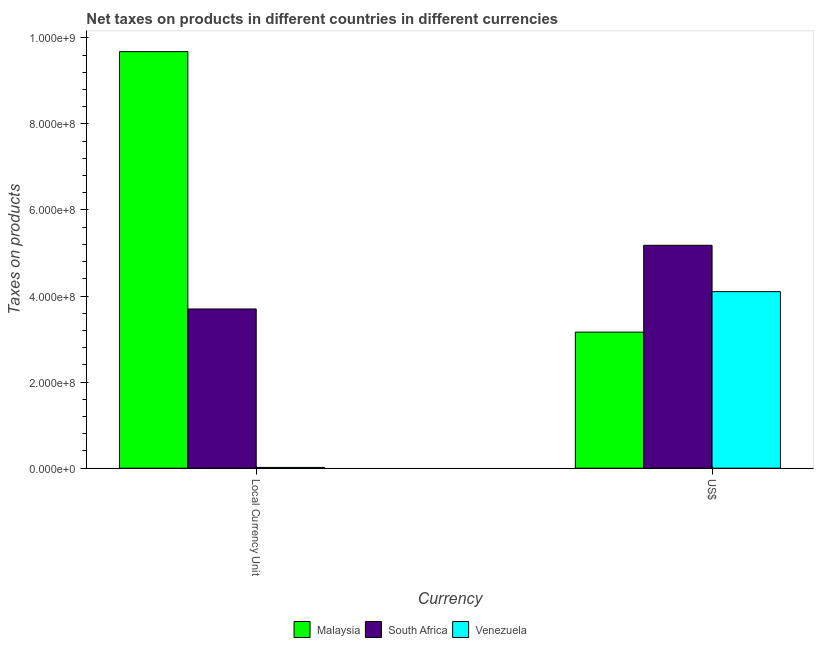How many different coloured bars are there?
Provide a succinct answer. 3. How many groups of bars are there?
Ensure brevity in your answer.  2. Are the number of bars per tick equal to the number of legend labels?
Your answer should be compact. Yes. What is the label of the 2nd group of bars from the left?
Provide a short and direct response. US$. What is the net taxes in constant 2005 us$ in Venezuela?
Ensure brevity in your answer.  1.80e+06. Across all countries, what is the maximum net taxes in us$?
Ensure brevity in your answer.  5.18e+08. Across all countries, what is the minimum net taxes in us$?
Provide a succinct answer. 3.16e+08. In which country was the net taxes in constant 2005 us$ maximum?
Your answer should be very brief. Malaysia. In which country was the net taxes in us$ minimum?
Your answer should be compact. Malaysia. What is the total net taxes in constant 2005 us$ in the graph?
Make the answer very short. 1.34e+09. What is the difference between the net taxes in us$ in Venezuela and that in Malaysia?
Make the answer very short. 9.41e+07. What is the difference between the net taxes in us$ in Venezuela and the net taxes in constant 2005 us$ in South Africa?
Provide a succinct answer. 4.03e+07. What is the average net taxes in constant 2005 us$ per country?
Your answer should be very brief. 4.47e+08. What is the difference between the net taxes in constant 2005 us$ and net taxes in us$ in Venezuela?
Give a very brief answer. -4.09e+08. What is the ratio of the net taxes in constant 2005 us$ in South Africa to that in Malaysia?
Give a very brief answer. 0.38. Is the net taxes in us$ in Venezuela less than that in Malaysia?
Make the answer very short. No. In how many countries, is the net taxes in us$ greater than the average net taxes in us$ taken over all countries?
Your response must be concise. 1. What does the 1st bar from the left in US$ represents?
Your answer should be compact. Malaysia. What does the 1st bar from the right in Local Currency Unit represents?
Provide a succinct answer. Venezuela. How many bars are there?
Your response must be concise. 6. Are all the bars in the graph horizontal?
Your response must be concise. No. How many countries are there in the graph?
Make the answer very short. 3. What is the difference between two consecutive major ticks on the Y-axis?
Offer a very short reply. 2.00e+08. Does the graph contain grids?
Offer a terse response. No. How many legend labels are there?
Give a very brief answer. 3. How are the legend labels stacked?
Keep it short and to the point. Horizontal. What is the title of the graph?
Give a very brief answer. Net taxes on products in different countries in different currencies. Does "Cambodia" appear as one of the legend labels in the graph?
Provide a succinct answer. No. What is the label or title of the X-axis?
Provide a succinct answer. Currency. What is the label or title of the Y-axis?
Provide a succinct answer. Taxes on products. What is the Taxes on products in Malaysia in Local Currency Unit?
Make the answer very short. 9.68e+08. What is the Taxes on products in South Africa in Local Currency Unit?
Your answer should be compact. 3.70e+08. What is the Taxes on products of Venezuela in Local Currency Unit?
Provide a short and direct response. 1.80e+06. What is the Taxes on products in Malaysia in US$?
Your answer should be very brief. 3.16e+08. What is the Taxes on products of South Africa in US$?
Offer a terse response. 5.18e+08. What is the Taxes on products in Venezuela in US$?
Your answer should be very brief. 4.10e+08. Across all Currency, what is the maximum Taxes on products in Malaysia?
Your response must be concise. 9.68e+08. Across all Currency, what is the maximum Taxes on products of South Africa?
Ensure brevity in your answer.  5.18e+08. Across all Currency, what is the maximum Taxes on products of Venezuela?
Your answer should be very brief. 4.10e+08. Across all Currency, what is the minimum Taxes on products of Malaysia?
Provide a succinct answer. 3.16e+08. Across all Currency, what is the minimum Taxes on products in South Africa?
Your answer should be compact. 3.70e+08. Across all Currency, what is the minimum Taxes on products in Venezuela?
Give a very brief answer. 1.80e+06. What is the total Taxes on products in Malaysia in the graph?
Your answer should be compact. 1.28e+09. What is the total Taxes on products in South Africa in the graph?
Your response must be concise. 8.88e+08. What is the total Taxes on products of Venezuela in the graph?
Your answer should be very brief. 4.12e+08. What is the difference between the Taxes on products of Malaysia in Local Currency Unit and that in US$?
Make the answer very short. 6.52e+08. What is the difference between the Taxes on products in South Africa in Local Currency Unit and that in US$?
Provide a short and direct response. -1.48e+08. What is the difference between the Taxes on products in Venezuela in Local Currency Unit and that in US$?
Offer a terse response. -4.09e+08. What is the difference between the Taxes on products of Malaysia in Local Currency Unit and the Taxes on products of South Africa in US$?
Make the answer very short. 4.50e+08. What is the difference between the Taxes on products in Malaysia in Local Currency Unit and the Taxes on products in Venezuela in US$?
Offer a terse response. 5.58e+08. What is the difference between the Taxes on products of South Africa in Local Currency Unit and the Taxes on products of Venezuela in US$?
Provide a short and direct response. -4.03e+07. What is the average Taxes on products of Malaysia per Currency?
Offer a terse response. 6.42e+08. What is the average Taxes on products of South Africa per Currency?
Provide a short and direct response. 4.44e+08. What is the average Taxes on products in Venezuela per Currency?
Make the answer very short. 2.06e+08. What is the difference between the Taxes on products of Malaysia and Taxes on products of South Africa in Local Currency Unit?
Provide a short and direct response. 5.98e+08. What is the difference between the Taxes on products of Malaysia and Taxes on products of Venezuela in Local Currency Unit?
Offer a very short reply. 9.66e+08. What is the difference between the Taxes on products of South Africa and Taxes on products of Venezuela in Local Currency Unit?
Your answer should be very brief. 3.68e+08. What is the difference between the Taxes on products in Malaysia and Taxes on products in South Africa in US$?
Your response must be concise. -2.02e+08. What is the difference between the Taxes on products in Malaysia and Taxes on products in Venezuela in US$?
Ensure brevity in your answer.  -9.41e+07. What is the difference between the Taxes on products of South Africa and Taxes on products of Venezuela in US$?
Keep it short and to the point. 1.08e+08. What is the ratio of the Taxes on products in Malaysia in Local Currency Unit to that in US$?
Offer a very short reply. 3.06. What is the ratio of the Taxes on products in Venezuela in Local Currency Unit to that in US$?
Your answer should be very brief. 0. What is the difference between the highest and the second highest Taxes on products of Malaysia?
Give a very brief answer. 6.52e+08. What is the difference between the highest and the second highest Taxes on products in South Africa?
Offer a very short reply. 1.48e+08. What is the difference between the highest and the second highest Taxes on products in Venezuela?
Your answer should be compact. 4.09e+08. What is the difference between the highest and the lowest Taxes on products in Malaysia?
Your answer should be compact. 6.52e+08. What is the difference between the highest and the lowest Taxes on products in South Africa?
Offer a terse response. 1.48e+08. What is the difference between the highest and the lowest Taxes on products in Venezuela?
Offer a very short reply. 4.09e+08. 